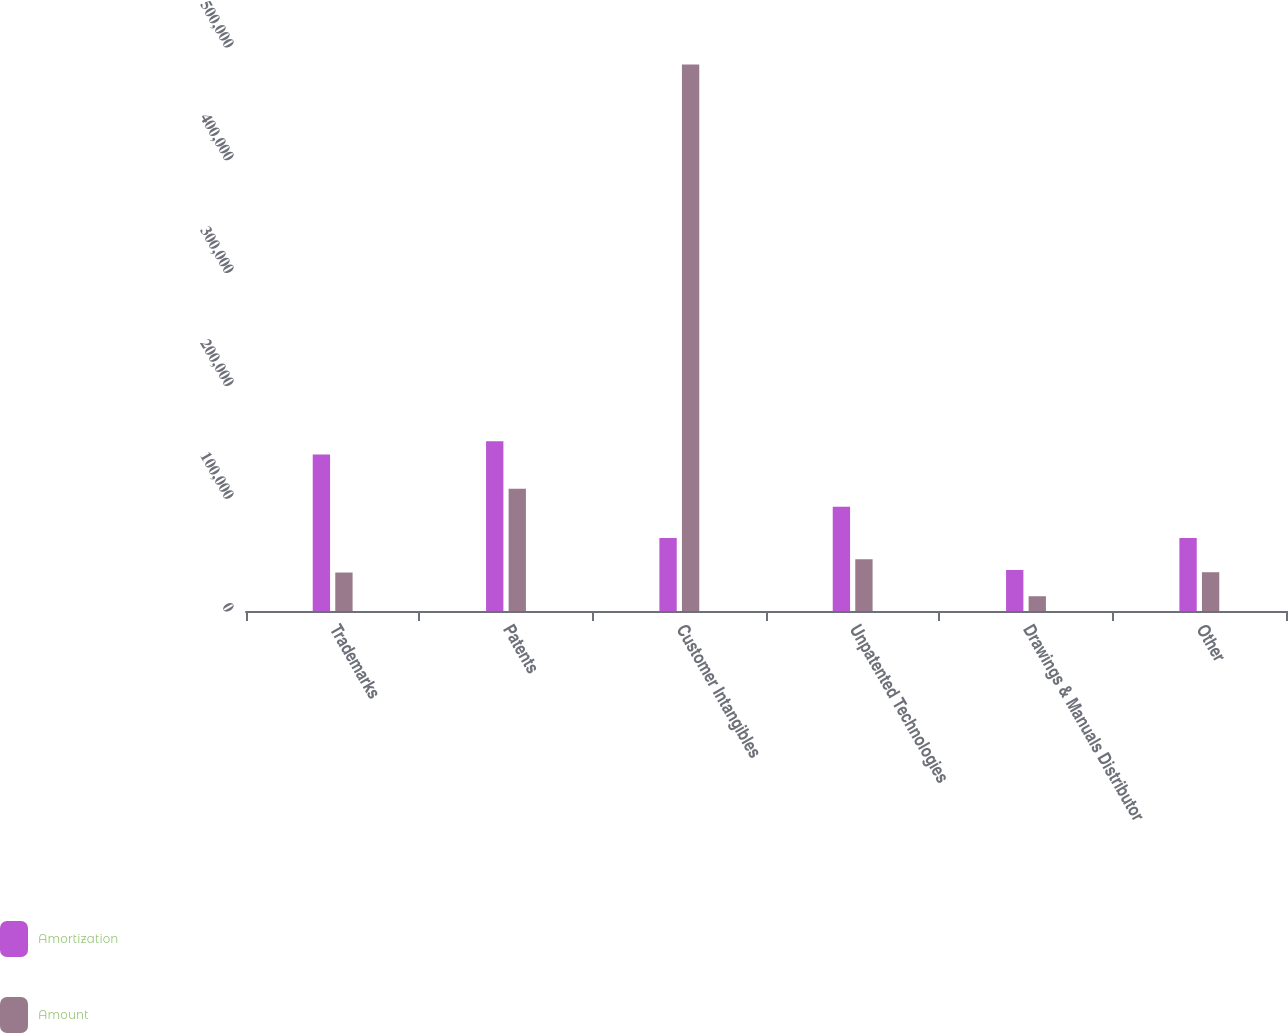<chart> <loc_0><loc_0><loc_500><loc_500><stacked_bar_chart><ecel><fcel>Trademarks<fcel>Patents<fcel>Customer Intangibles<fcel>Unpatented Technologies<fcel>Drawings & Manuals Distributor<fcel>Other<nl><fcel>Amortization<fcel>138650<fcel>150404<fcel>64614<fcel>92480<fcel>36377<fcel>64614<nl><fcel>Amount<fcel>34097<fcel>108484<fcel>484449<fcel>45812<fcel>13087<fcel>34377<nl></chart> 